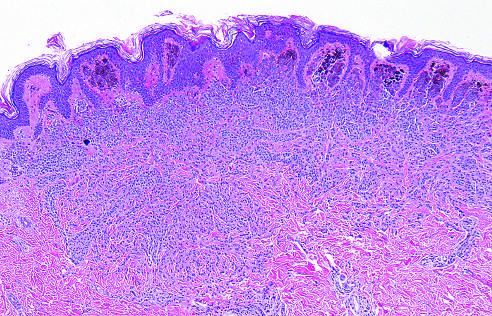s a nevus composed of melanocytes that lose pigmentation and become smaller and more dispersed as they extend into the dermis-all signs that speak to the benign nature of the proliferation?
Answer the question using a single word or phrase. Yes 